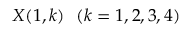Convert formula to latex. <formula><loc_0><loc_0><loc_500><loc_500>X ( 1 , k ) ( k = 1 , 2 , 3 , 4 )</formula> 